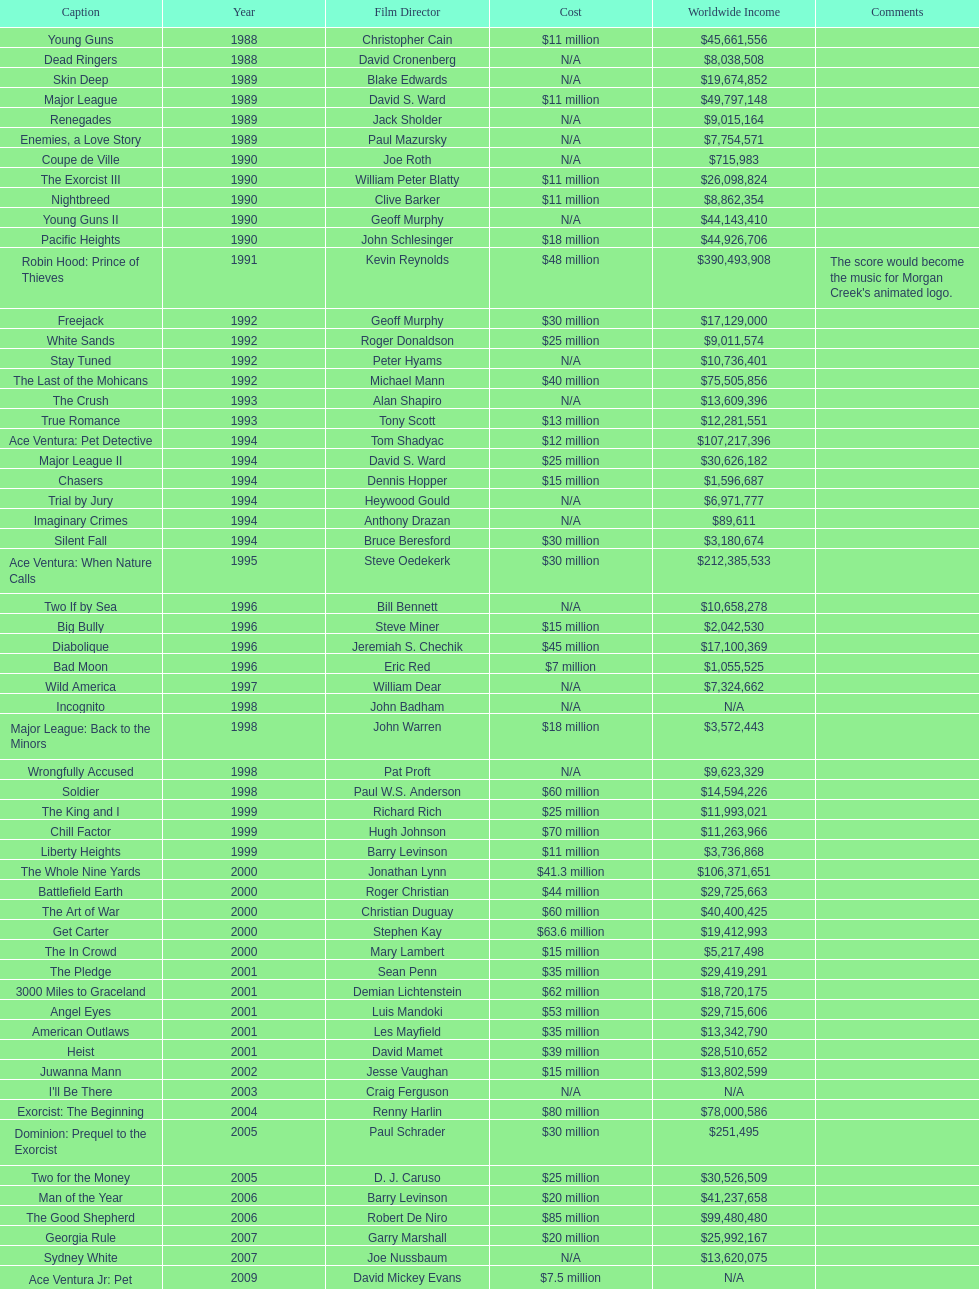What was the last movie morgan creek made for a budget under thirty million? Ace Ventura Jr: Pet Detective. 